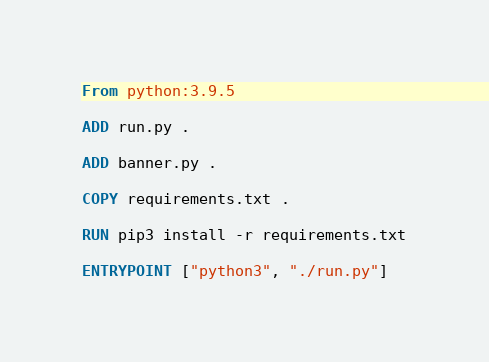<code> <loc_0><loc_0><loc_500><loc_500><_Dockerfile_>From python:3.9.5

ADD run.py .

ADD banner.py .

COPY requirements.txt .

RUN pip3 install -r requirements.txt

ENTRYPOINT ["python3", "./run.py"]</code> 